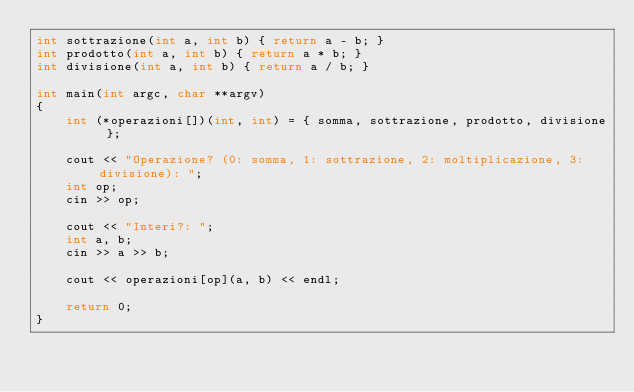Convert code to text. <code><loc_0><loc_0><loc_500><loc_500><_C++_>int sottrazione(int a, int b) { return a - b; }
int prodotto(int a, int b) { return a * b; }
int divisione(int a, int b) { return a / b; }

int main(int argc, char **argv)
{
    int (*operazioni[])(int, int) = { somma, sottrazione, prodotto, divisione };

    cout << "Operazione? (0: somma, 1: sottrazione, 2: moltiplicazione, 3: divisione): ";
    int op;
    cin >> op;

    cout << "Interi?: ";
    int a, b;
    cin >> a >> b;

    cout << operazioni[op](a, b) << endl;

    return 0;
}</code> 